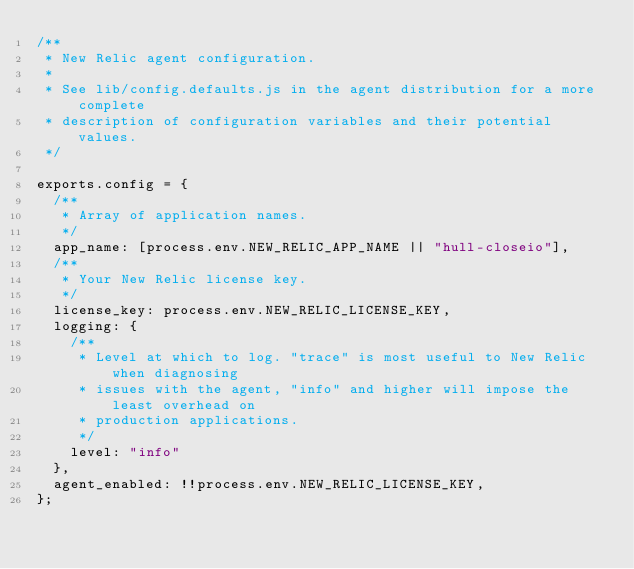<code> <loc_0><loc_0><loc_500><loc_500><_JavaScript_>/**
 * New Relic agent configuration.
 *
 * See lib/config.defaults.js in the agent distribution for a more complete
 * description of configuration variables and their potential values.
 */

exports.config = {
  /**
   * Array of application names.
   */
  app_name: [process.env.NEW_RELIC_APP_NAME || "hull-closeio"],
  /**
   * Your New Relic license key.
   */
  license_key: process.env.NEW_RELIC_LICENSE_KEY,
  logging: {
    /**
     * Level at which to log. "trace" is most useful to New Relic when diagnosing
     * issues with the agent, "info" and higher will impose the least overhead on
     * production applications.
     */
    level: "info"
  },
  agent_enabled: !!process.env.NEW_RELIC_LICENSE_KEY,
};
</code> 